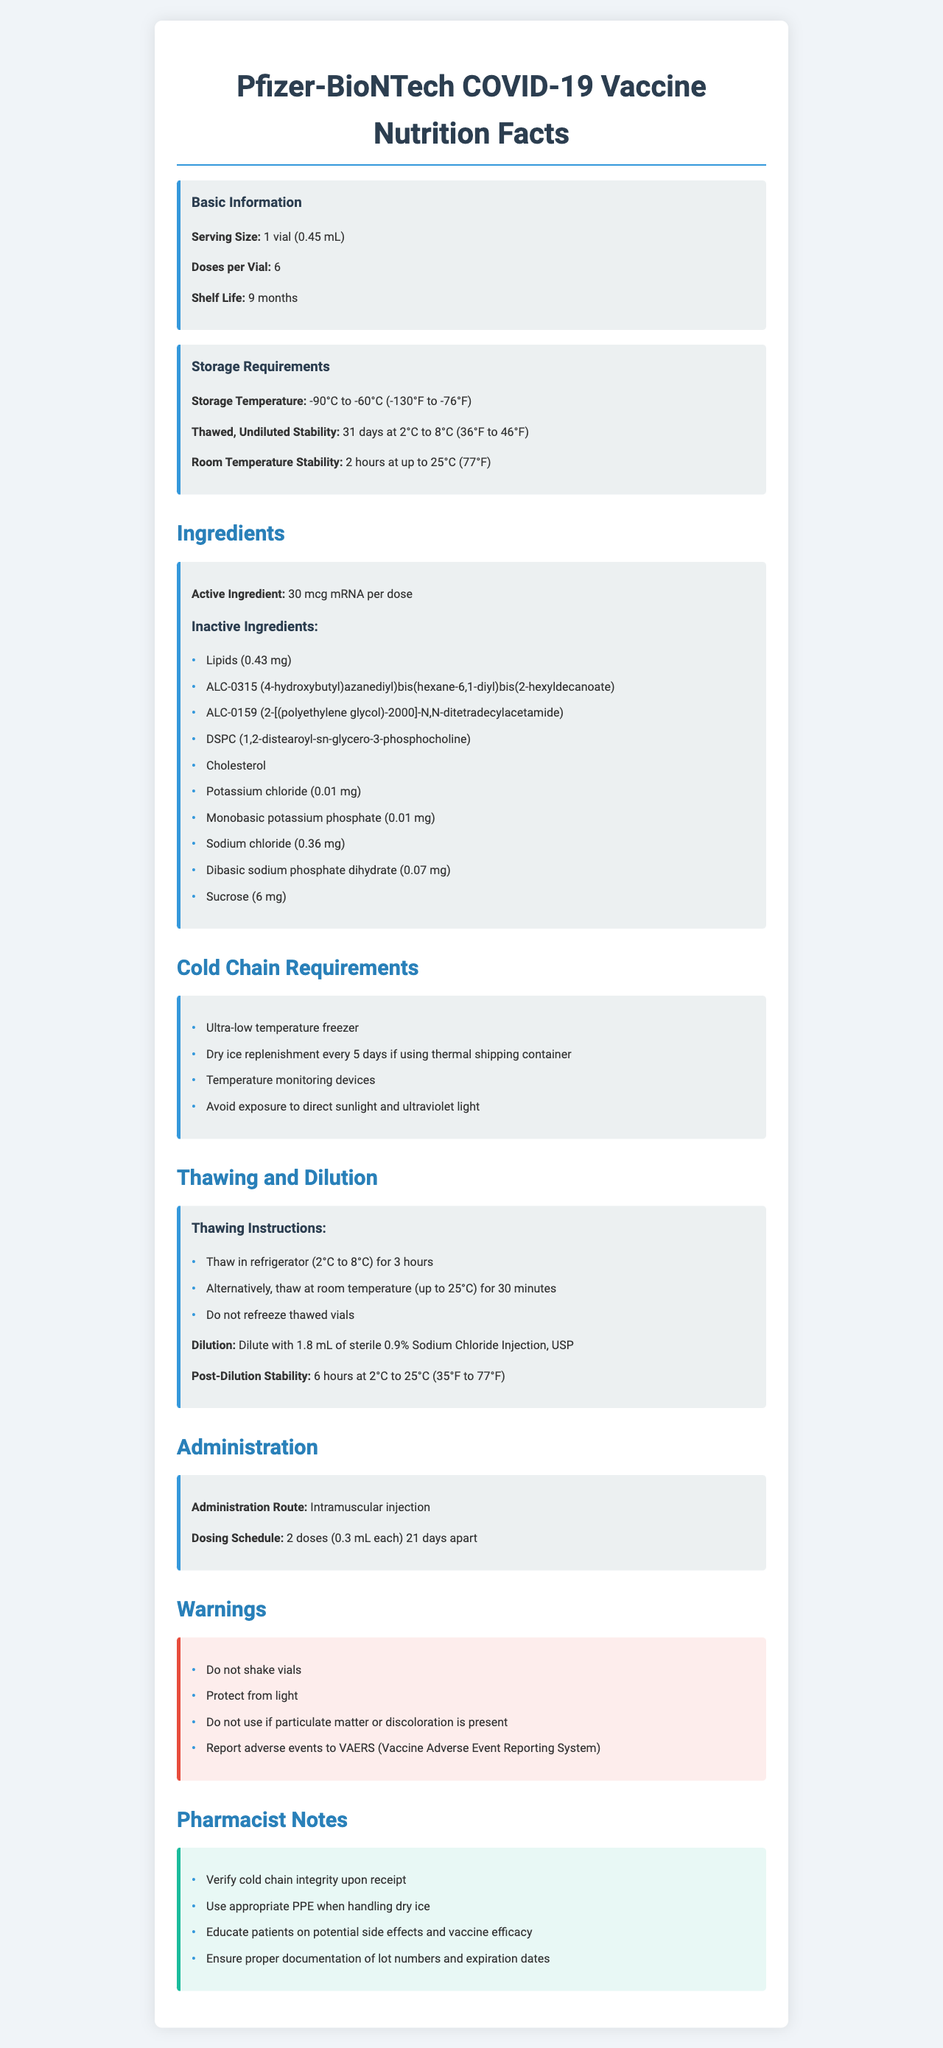What is the product name? The product name is prominently displayed at the top of the document.
Answer: Pfizer-BioNTech COVID-19 Vaccine What is the storage temperature requirement for the Pfizer-BioNTech COVID-19 Vaccine? The storage temperature requirement is clearly listed under "Storage Requirements."
Answer: -90°C to -60°C (-130°F to -76°F) How many doses are there in one vial of Pfizer-BioNTech COVID-19 Vaccine? The document states that there are 6 doses per vial.
Answer: 6 doses How long is the shelf life of the Pfizer-BioNTech COVID-19 Vaccine? The shelf life is mentioned in the “Basic Information” section.
Answer: 9 months What should you do if the vaccine vial shows particulate matter or discoloration? The warning section clearly states not to use the vaccine if particulate matter or discoloration is present.
Answer: Do not use Which temperature stability period is longer, thawed and undiluted at 2°C to 8°C or post-diluted at 2°C to 25°C? Thawed, undiluted stability lasts for 31 days while post-diluted stability lasts for 6 hours.
Answer: Thawed and undiluted at 2°C to 8°C What is the room temperature stability for the undiluted vaccine? The room temperature stability is specified under "Storage Requirements."
Answer: 2 hours at up to 25°C (77°F) What type of PPE (Personal Protective Equipment) should be used when handling dry ice? The note for pharmacists indicates that appropriate PPE should be used.
Answer: Appropriate PPE What is the purpose of thawing instructions in handling the Pfizer-BioNTech COVID-19 Vaccine? The thawing instructions provide detailed steps to safely thaw the vaccine either in a refrigerator or at room temperature.
Answer: To guide proper thawing of the vaccine What is the active ingredient in the Pfizer-BioNTech COVID-19 Vaccine? A. Lipids B. mRNA C. Cholesterol D. Sodium chloride The active ingredient is clearly listed as "30 mcg mRNA per dose."
Answer: B. mRNA For how long can the vaccine remain stable once thawed and undiluted at 2°C to 8°C (36°F to 46°F)? A. 6 hours B. 9 months C. 31 days D. 2 hours The document specifies 31 days for thawed, undiluted stability at 2°C to 8°C.
Answer: C. 31 days Can thawed vials of the Pfizer-BioNTech COVID-19 Vaccine be refrozen? The thawing instructions clearly state that thawed vials should not be refrozen.
Answer: No Summarize the main purpose of the document. The main purpose of the document is to guide pharmacists and healthcare professionals in the proper handling and administration of the Pfizer-BioNTech COVID-19 Vaccine.
Answer: This document provides detailed information on the Pfizer-BioNTech COVID-19 Vaccine, including storage requirements, ingredients, thawing and dilution instructions, administration guidelines, warnings, and notes for pharmacists. What should be the frequency of dry ice replenishment if using a thermal shipping container? The cold chain requirements section states dry ice should be replenished every 5 days.
Answer: Every 5 days What is the dosage schedule for the Pfizer-BioNTech COVID-19 Vaccine? The dosing schedule specifies that the vaccine is given in 2 doses, 21 days apart.
Answer: 2 doses (0.3 mL each) 21 days apart What is the storage instruction concerning light exposure for the Pfizer-BioNTech COVID-19 Vaccine? The document warns to protect the vials from light exposure.
Answer: Protect from light What is the dilution requirement for the Pfizer-BioNTech COVID-19 Vaccine? The document provides specific instructions for dilution.
Answer: Dilute with 1.8 mL of sterile 0.9% Sodium Chloride Injection, USP Does the document provide information about adverse reactions to the vaccine? While the document advises to report adverse events to VAERS, it does not provide detailed information on specific adverse reactions.
Answer: Not enough information 